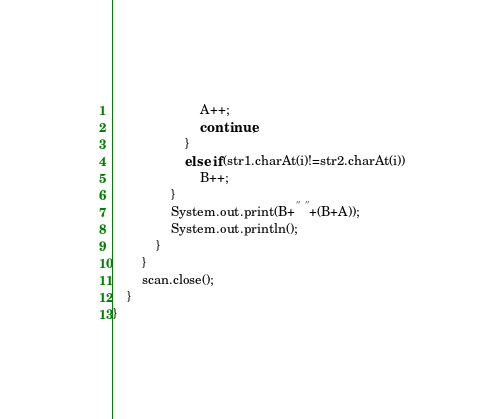Convert code to text. <code><loc_0><loc_0><loc_500><loc_500><_Java_>		                A++;
		                continue;
		            }
		            else if(str1.charAt(i)!=str2.charAt(i))
		                B++;
		        }
		        System.out.print(B+" "+(B+A));
		        System.out.println();
		    }
        }
        scan.close();
	}
}
</code> 